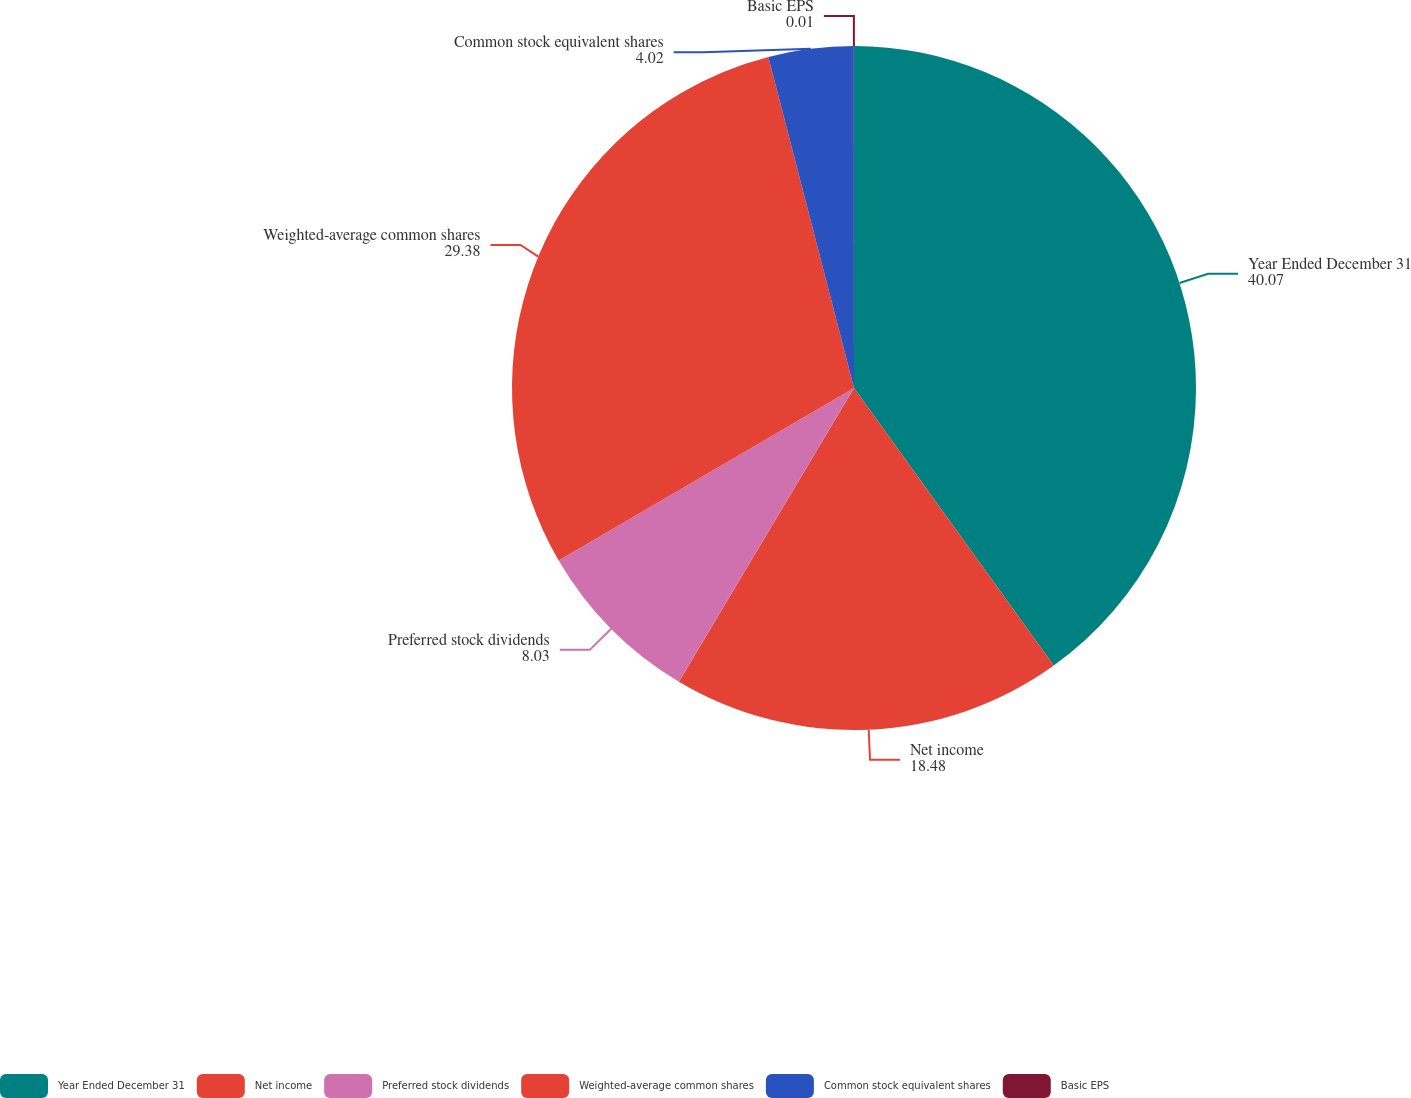<chart> <loc_0><loc_0><loc_500><loc_500><pie_chart><fcel>Year Ended December 31<fcel>Net income<fcel>Preferred stock dividends<fcel>Weighted-average common shares<fcel>Common stock equivalent shares<fcel>Basic EPS<nl><fcel>40.07%<fcel>18.48%<fcel>8.03%<fcel>29.38%<fcel>4.02%<fcel>0.01%<nl></chart> 